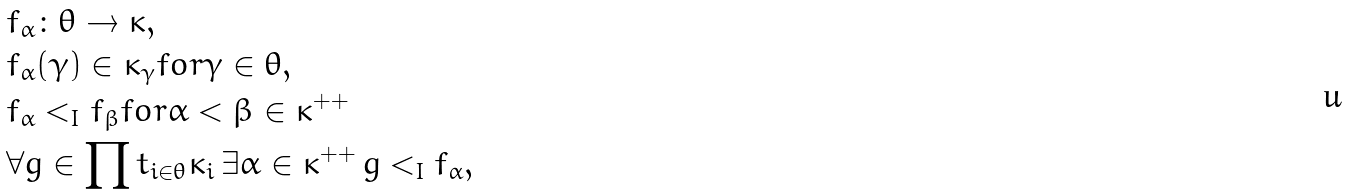<formula> <loc_0><loc_0><loc_500><loc_500>& f _ { \alpha } \colon \theta \to \kappa , \\ & f _ { \alpha } ( \gamma ) \in \kappa _ { \gamma } f o r \gamma \in \theta , \\ & f _ { \alpha } < _ { I } f _ { \beta } f o r \alpha < \beta \in \kappa ^ { + + } \\ & \forall g \in \prod t _ { i \in \theta } \kappa _ { i } \, \exists \alpha \in \kappa ^ { + + } \, g < _ { I } f _ { \alpha } ,</formula> 